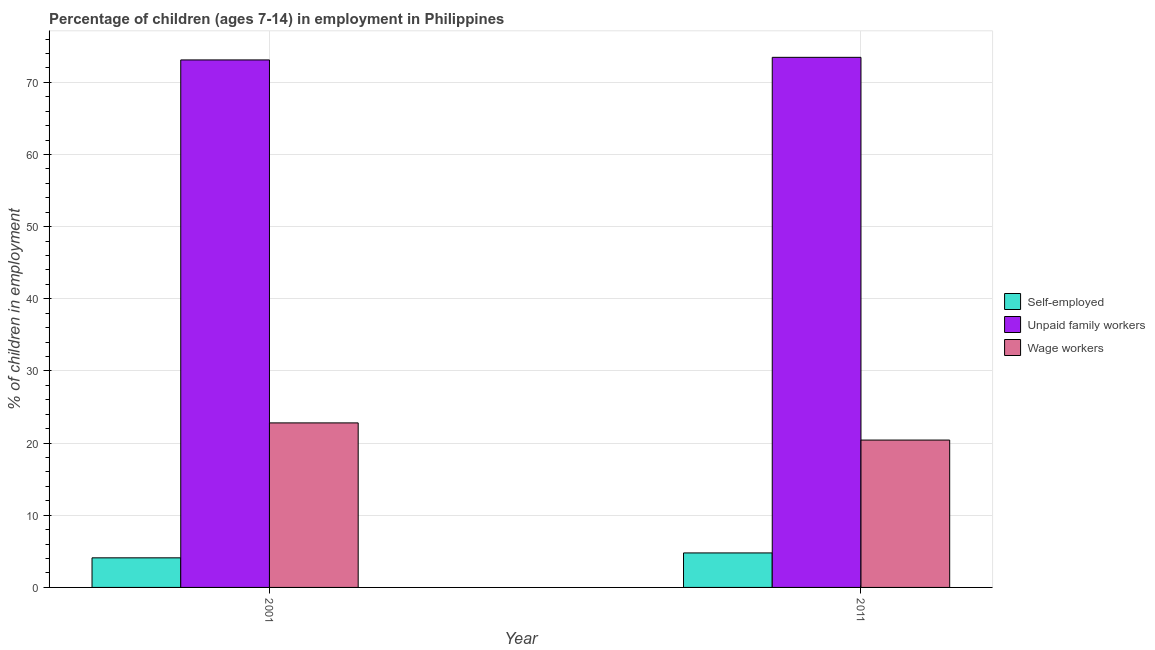How many different coloured bars are there?
Your answer should be compact. 3. How many bars are there on the 1st tick from the right?
Offer a terse response. 3. What is the percentage of children employed as unpaid family workers in 2011?
Your response must be concise. 73.46. Across all years, what is the maximum percentage of children employed as wage workers?
Provide a short and direct response. 22.8. What is the total percentage of children employed as unpaid family workers in the graph?
Your answer should be compact. 146.56. What is the difference between the percentage of children employed as unpaid family workers in 2001 and that in 2011?
Your response must be concise. -0.36. What is the difference between the percentage of children employed as wage workers in 2011 and the percentage of children employed as unpaid family workers in 2001?
Offer a very short reply. -2.38. What is the average percentage of children employed as unpaid family workers per year?
Provide a succinct answer. 73.28. In the year 2001, what is the difference between the percentage of self employed children and percentage of children employed as unpaid family workers?
Provide a succinct answer. 0. What is the ratio of the percentage of children employed as wage workers in 2001 to that in 2011?
Provide a succinct answer. 1.12. In how many years, is the percentage of self employed children greater than the average percentage of self employed children taken over all years?
Ensure brevity in your answer.  1. What does the 2nd bar from the left in 2001 represents?
Give a very brief answer. Unpaid family workers. What does the 1st bar from the right in 2001 represents?
Your answer should be very brief. Wage workers. Are all the bars in the graph horizontal?
Your answer should be compact. No. Are the values on the major ticks of Y-axis written in scientific E-notation?
Ensure brevity in your answer.  No. Does the graph contain grids?
Ensure brevity in your answer.  Yes. How many legend labels are there?
Keep it short and to the point. 3. How are the legend labels stacked?
Offer a terse response. Vertical. What is the title of the graph?
Provide a succinct answer. Percentage of children (ages 7-14) in employment in Philippines. What is the label or title of the X-axis?
Offer a terse response. Year. What is the label or title of the Y-axis?
Make the answer very short. % of children in employment. What is the % of children in employment in Self-employed in 2001?
Give a very brief answer. 4.1. What is the % of children in employment in Unpaid family workers in 2001?
Keep it short and to the point. 73.1. What is the % of children in employment in Wage workers in 2001?
Your response must be concise. 22.8. What is the % of children in employment in Self-employed in 2011?
Offer a very short reply. 4.78. What is the % of children in employment of Unpaid family workers in 2011?
Your response must be concise. 73.46. What is the % of children in employment of Wage workers in 2011?
Your answer should be compact. 20.42. Across all years, what is the maximum % of children in employment in Self-employed?
Provide a short and direct response. 4.78. Across all years, what is the maximum % of children in employment of Unpaid family workers?
Keep it short and to the point. 73.46. Across all years, what is the maximum % of children in employment in Wage workers?
Provide a short and direct response. 22.8. Across all years, what is the minimum % of children in employment of Unpaid family workers?
Provide a short and direct response. 73.1. Across all years, what is the minimum % of children in employment in Wage workers?
Ensure brevity in your answer.  20.42. What is the total % of children in employment in Self-employed in the graph?
Your answer should be compact. 8.88. What is the total % of children in employment of Unpaid family workers in the graph?
Keep it short and to the point. 146.56. What is the total % of children in employment of Wage workers in the graph?
Keep it short and to the point. 43.22. What is the difference between the % of children in employment in Self-employed in 2001 and that in 2011?
Provide a short and direct response. -0.68. What is the difference between the % of children in employment in Unpaid family workers in 2001 and that in 2011?
Your answer should be compact. -0.36. What is the difference between the % of children in employment in Wage workers in 2001 and that in 2011?
Keep it short and to the point. 2.38. What is the difference between the % of children in employment of Self-employed in 2001 and the % of children in employment of Unpaid family workers in 2011?
Offer a terse response. -69.36. What is the difference between the % of children in employment in Self-employed in 2001 and the % of children in employment in Wage workers in 2011?
Your response must be concise. -16.32. What is the difference between the % of children in employment of Unpaid family workers in 2001 and the % of children in employment of Wage workers in 2011?
Keep it short and to the point. 52.68. What is the average % of children in employment in Self-employed per year?
Provide a short and direct response. 4.44. What is the average % of children in employment of Unpaid family workers per year?
Provide a short and direct response. 73.28. What is the average % of children in employment of Wage workers per year?
Ensure brevity in your answer.  21.61. In the year 2001, what is the difference between the % of children in employment of Self-employed and % of children in employment of Unpaid family workers?
Your answer should be compact. -69. In the year 2001, what is the difference between the % of children in employment of Self-employed and % of children in employment of Wage workers?
Keep it short and to the point. -18.7. In the year 2001, what is the difference between the % of children in employment of Unpaid family workers and % of children in employment of Wage workers?
Provide a succinct answer. 50.3. In the year 2011, what is the difference between the % of children in employment in Self-employed and % of children in employment in Unpaid family workers?
Provide a succinct answer. -68.68. In the year 2011, what is the difference between the % of children in employment of Self-employed and % of children in employment of Wage workers?
Offer a very short reply. -15.64. In the year 2011, what is the difference between the % of children in employment in Unpaid family workers and % of children in employment in Wage workers?
Give a very brief answer. 53.04. What is the ratio of the % of children in employment of Self-employed in 2001 to that in 2011?
Offer a very short reply. 0.86. What is the ratio of the % of children in employment in Unpaid family workers in 2001 to that in 2011?
Ensure brevity in your answer.  1. What is the ratio of the % of children in employment in Wage workers in 2001 to that in 2011?
Your answer should be compact. 1.12. What is the difference between the highest and the second highest % of children in employment in Self-employed?
Offer a very short reply. 0.68. What is the difference between the highest and the second highest % of children in employment of Unpaid family workers?
Your response must be concise. 0.36. What is the difference between the highest and the second highest % of children in employment in Wage workers?
Provide a short and direct response. 2.38. What is the difference between the highest and the lowest % of children in employment in Self-employed?
Give a very brief answer. 0.68. What is the difference between the highest and the lowest % of children in employment of Unpaid family workers?
Make the answer very short. 0.36. What is the difference between the highest and the lowest % of children in employment of Wage workers?
Offer a very short reply. 2.38. 